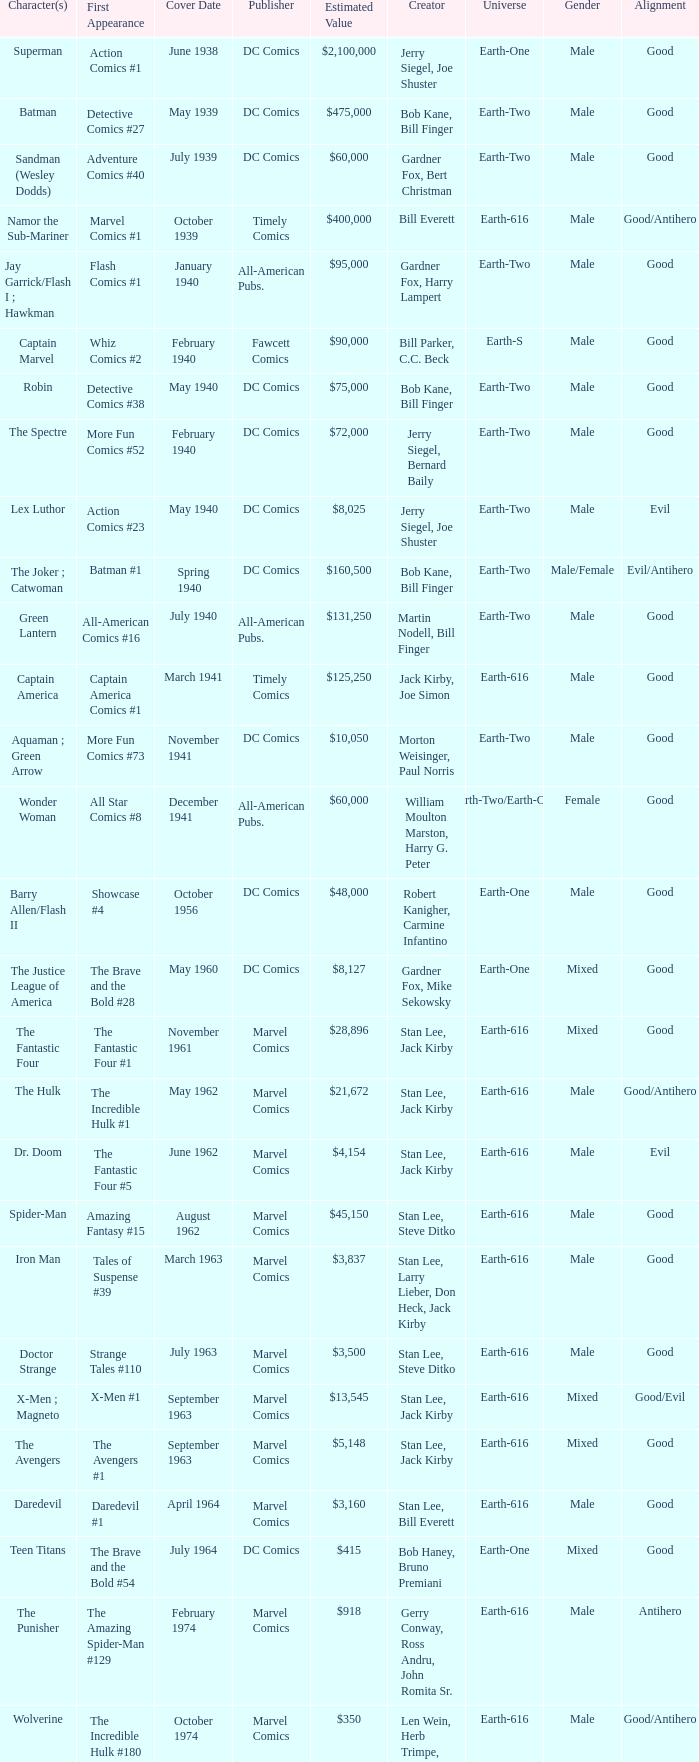Who publishes Wolverine? Marvel Comics. 